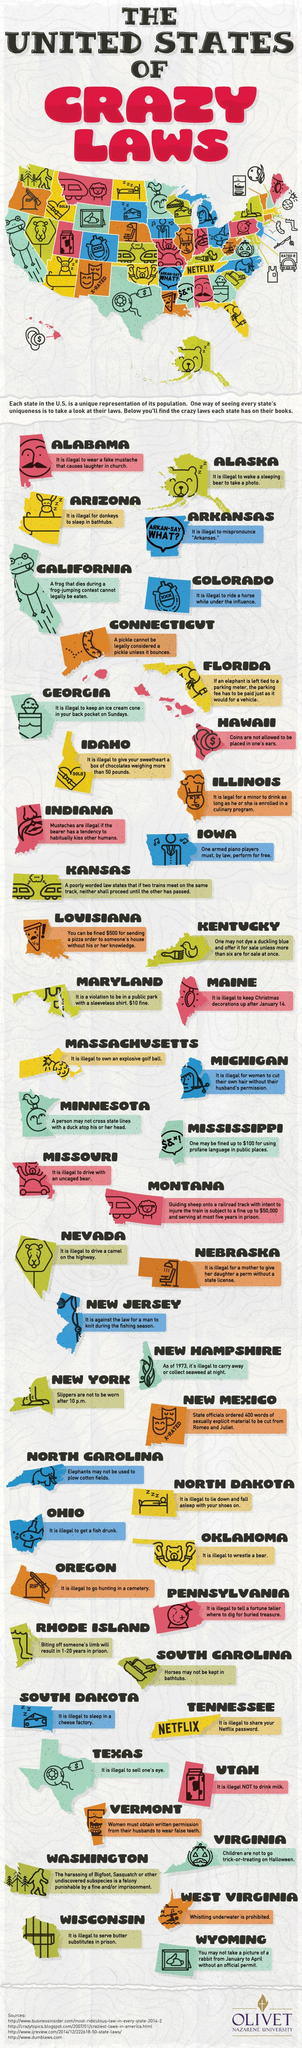Identify some key points in this picture. In the state of Maine, there is a law that makes it illegal to keep Christmas decorations up after January 14th. 